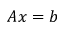Convert formula to latex. <formula><loc_0><loc_0><loc_500><loc_500>A x = b</formula> 